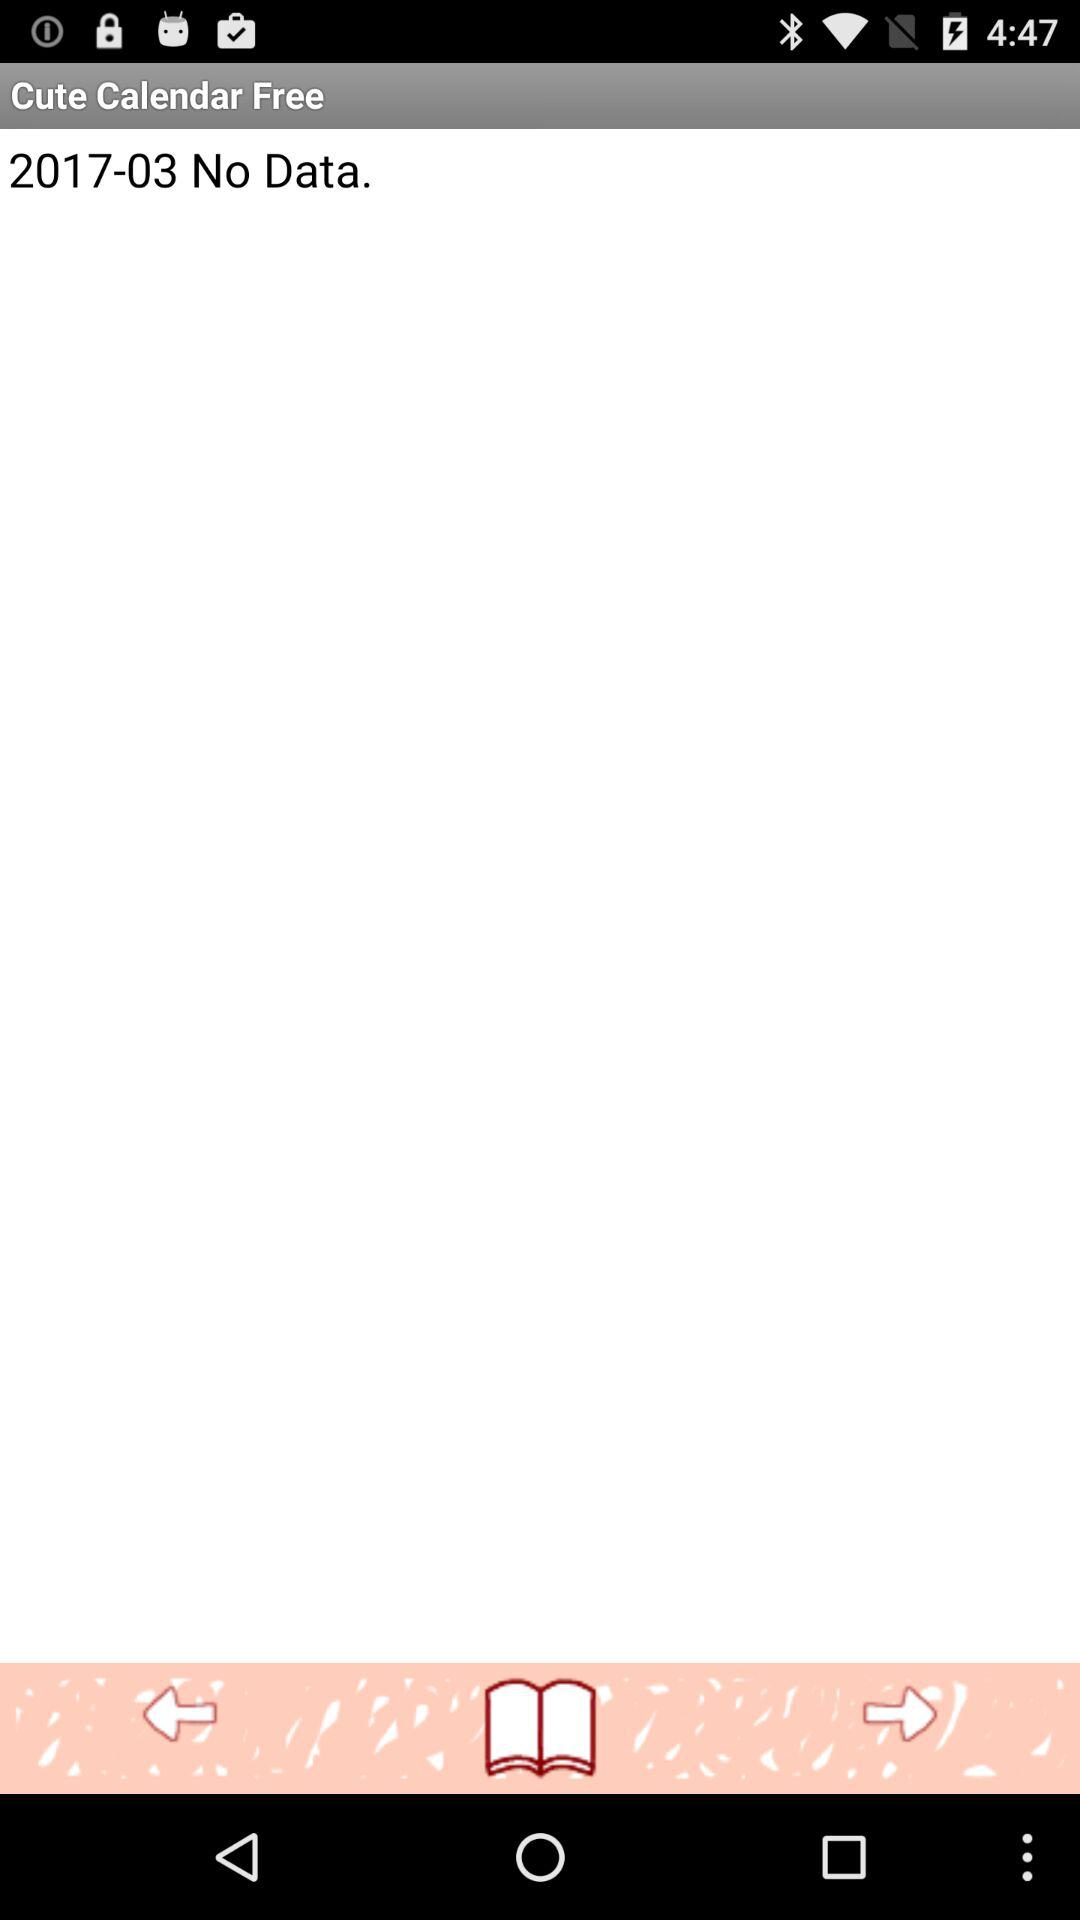Is there any data in March, 2017? There is no data present. 